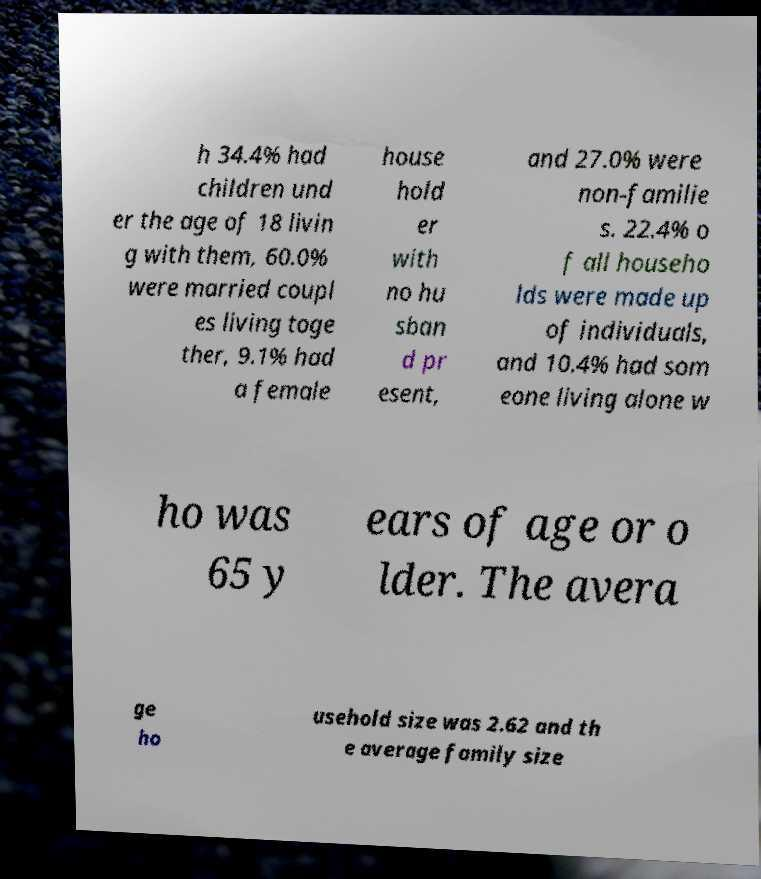Please identify and transcribe the text found in this image. h 34.4% had children und er the age of 18 livin g with them, 60.0% were married coupl es living toge ther, 9.1% had a female house hold er with no hu sban d pr esent, and 27.0% were non-familie s. 22.4% o f all househo lds were made up of individuals, and 10.4% had som eone living alone w ho was 65 y ears of age or o lder. The avera ge ho usehold size was 2.62 and th e average family size 